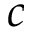Convert formula to latex. <formula><loc_0><loc_0><loc_500><loc_500>c</formula> 